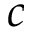Convert formula to latex. <formula><loc_0><loc_0><loc_500><loc_500>c</formula> 